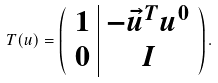<formula> <loc_0><loc_0><loc_500><loc_500>T ( u ) = \left ( \begin{array} { c | c } 1 & - \vec { u } ^ { T } u ^ { 0 } \\ 0 & I \end{array} \right ) .</formula> 